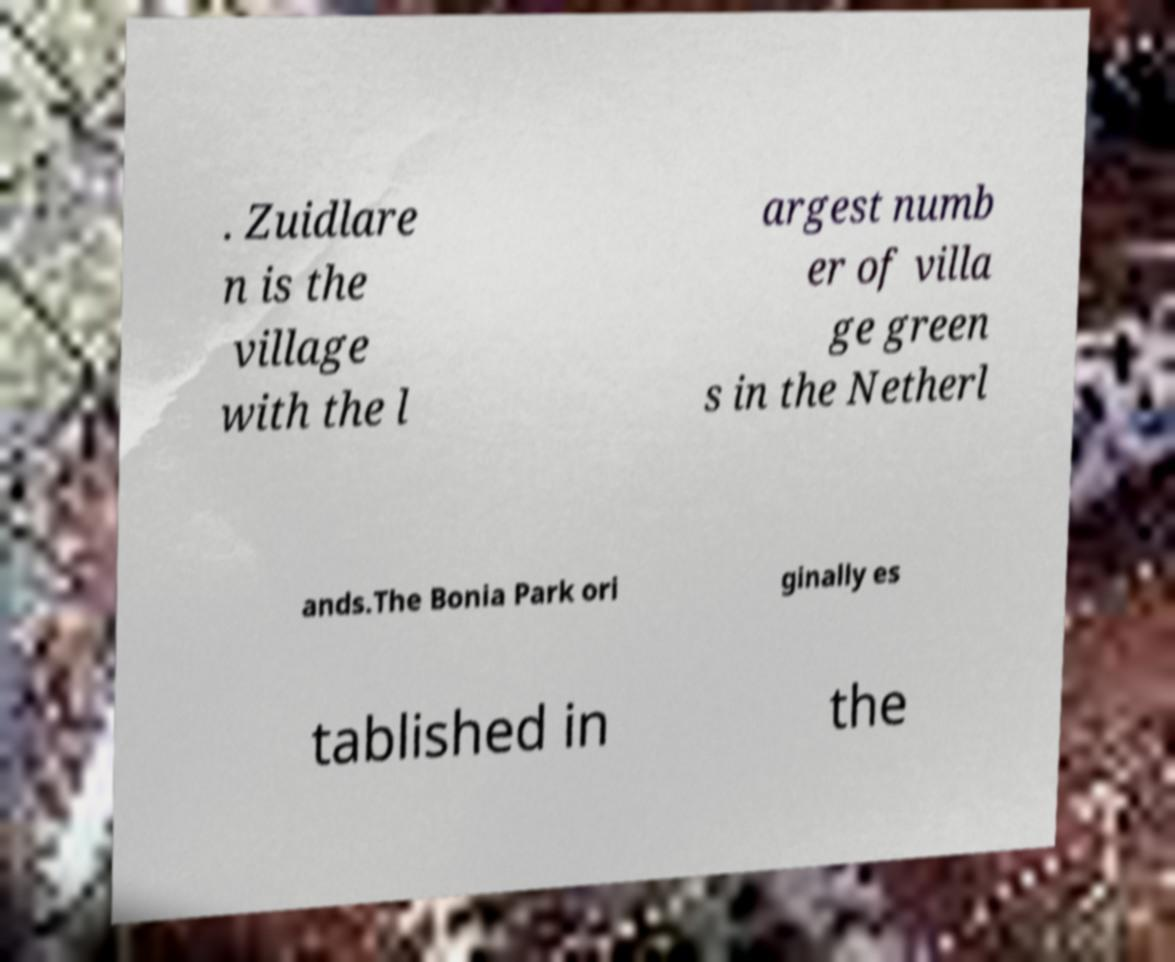Can you accurately transcribe the text from the provided image for me? . Zuidlare n is the village with the l argest numb er of villa ge green s in the Netherl ands.The Bonia Park ori ginally es tablished in the 